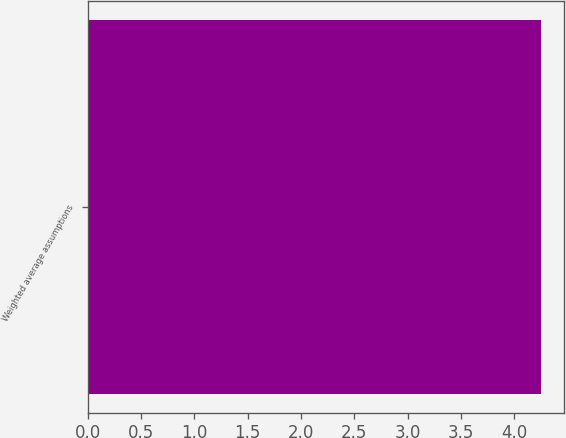<chart> <loc_0><loc_0><loc_500><loc_500><bar_chart><fcel>Weighted average assumptions<nl><fcel>4.25<nl></chart> 